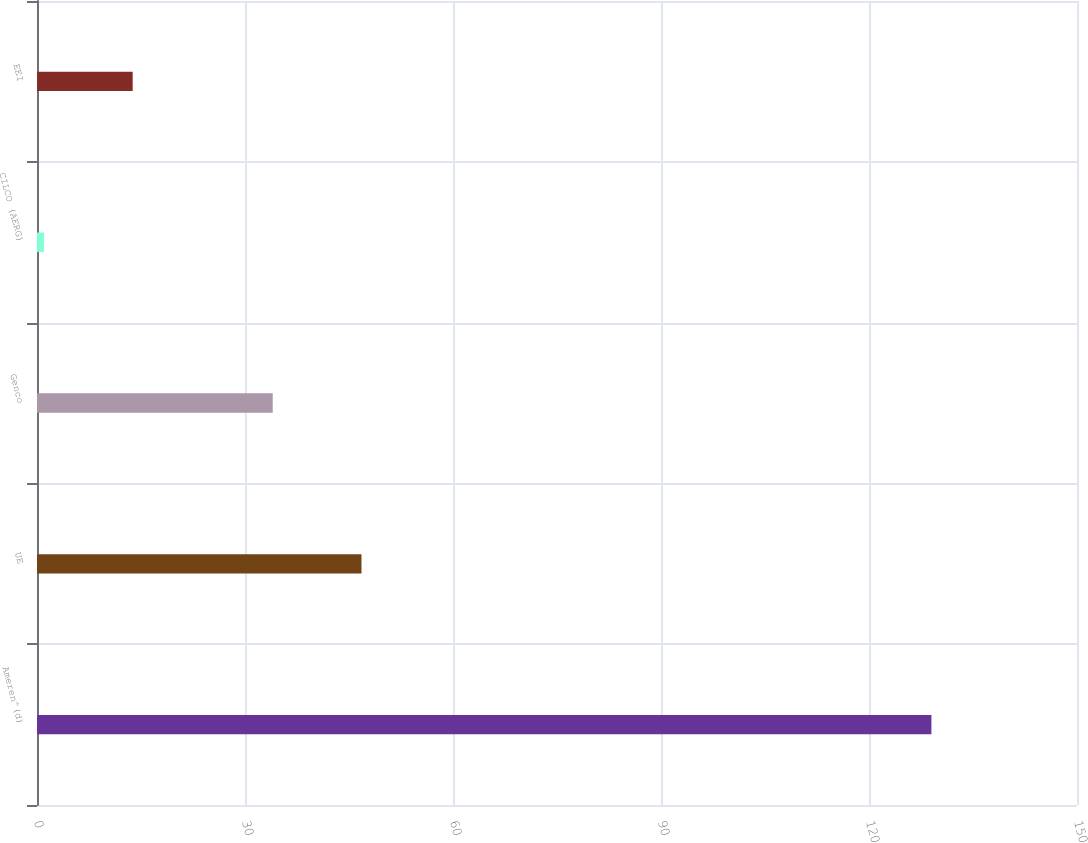Convert chart. <chart><loc_0><loc_0><loc_500><loc_500><bar_chart><fcel>Ameren^(d)<fcel>UE<fcel>Genco<fcel>CILCO (AERG)<fcel>EEI<nl><fcel>129<fcel>46.8<fcel>34<fcel>1<fcel>13.8<nl></chart> 